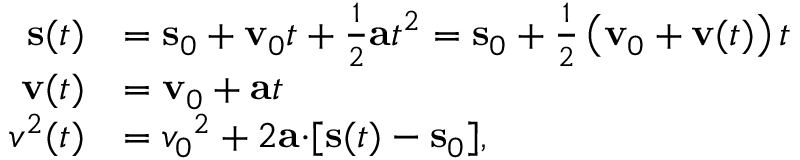Convert formula to latex. <formula><loc_0><loc_0><loc_500><loc_500>{ \begin{array} { r l } { s ( t ) } & { = s _ { 0 } + v _ { 0 } t + { \frac { 1 } { 2 } } a t ^ { 2 } = s _ { 0 } + { \frac { 1 } { 2 } } \left ( v _ { 0 } + v ( t ) \right ) t } \\ { v ( t ) } & { = v _ { 0 } + a t } \\ { { v ^ { 2 } } ( t ) } & { = { v _ { 0 } } ^ { 2 } + 2 a \cdot [ s ( t ) - s _ { 0 } ] , } \end{array} }</formula> 